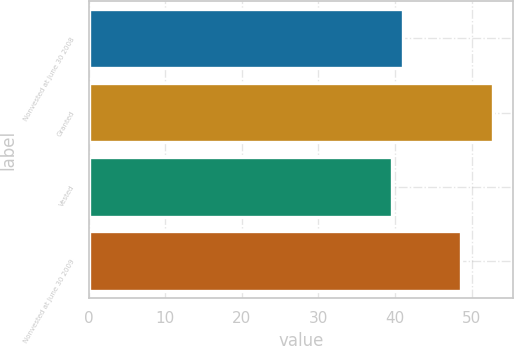Convert chart. <chart><loc_0><loc_0><loc_500><loc_500><bar_chart><fcel>Nonvested at June 30 2008<fcel>Granted<fcel>Vested<fcel>Nonvested at June 30 2009<nl><fcel>41.05<fcel>52.83<fcel>39.56<fcel>48.57<nl></chart> 